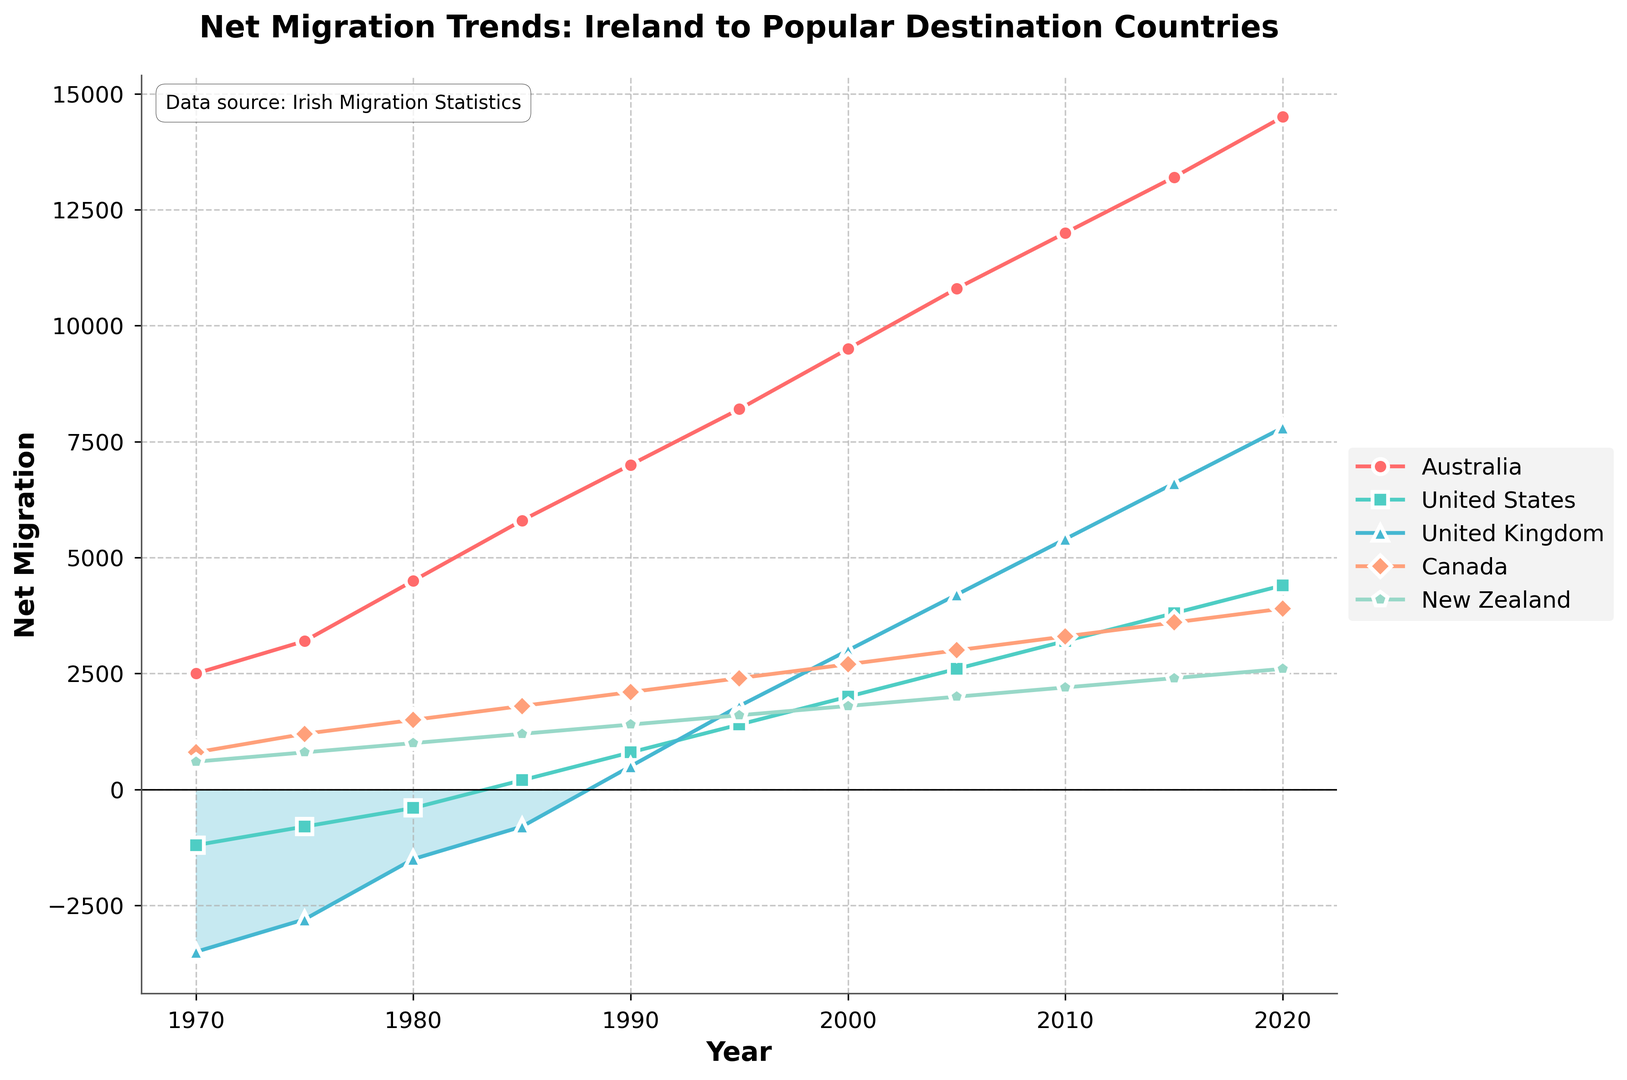What is the net migration trend for Ireland to Australia between 1970 and 2020? To determine the trend, we observe the line associated with Australia. It starts at 2500 in 1970 and gradually increases every 5 years, reaching 14500 in 2020. This indicates a steadily increasing positive trend in net migration to Australia.
Answer: Steadily increasing Between which two consecutive years did the United States see its most significant increase in net migration? To identify the largest increase, compare the differences in net migration between consecutive years. The differences are: (1970-1975: 400), (1975-1980: 400), (1980-1985: 600), (1985-1990: 600), (1990-1995: 600), (1995-2000: 600), (2000-2005: 600), (2005-2010: 600), (2010-2015: 600), (2015-2020: 600). The largest increase, 600, happened several times, e.g., between 1980 and 1985.
Answer: 1980 and 1985 Which country had negative net migration values at the beginning of the period but positive values by the end of the period? We look at the lines and see that the United States has negative values at the start in 1970 (-1200). Over the years, it moves into positive territory, reaching 4400 by 2020.
Answer: United States What was New Zealand's net migration value in 1990, and how does it compare to Canada's value in the same year? Find the net migration value for New Zealand in 1990, which is 1400. Then compare it to Canada's value in the same year, which is 2100. The net migration to New Zealand (1400) is less than to Canada (2100).
Answer: 1400, less than Canada By how much did net migration to the United Kingdom change from 1970 to 2020? Calculate the difference in net migration values for the United Kingdom between 1970 (-3500) and 2020 (7800). The change is 7800 - (-3500) = 11300.
Answer: 11300 Which country consistently shows positive net migration throughout the entire period? We examine each country line. Canada shows positive net migration values consistently, starting from 800 in 1970 and increasing steadily to 3900 in 2020.
Answer: Canada Comparing Australia and New Zealand, which country had higher net migration values in 1985? For 1985, Australia's net migration value is 5800, and New Zealand's is 1200. Australia has higher net migration values in 1985.
Answer: Australia What is the net migration for Ireland to Canada in 2000, and how does it compare to Australia's value in the same year? Check the line values for Canada (2000, 2700) and Australia (2000, 9500). Compare these values. Canada's net migration is 2700, which is less than Australia's 9500.
Answer: 2700, less than Australia Which country experienced the most significant decrease in net migration from 1970 to 1975? Calculate the decreases: United Kingdom decreased from -3500 to -2800 (change of 700). Other countries either increased or had smaller decreases. The United Kingdom experienced the most significant decrease.
Answer: United Kingdom 